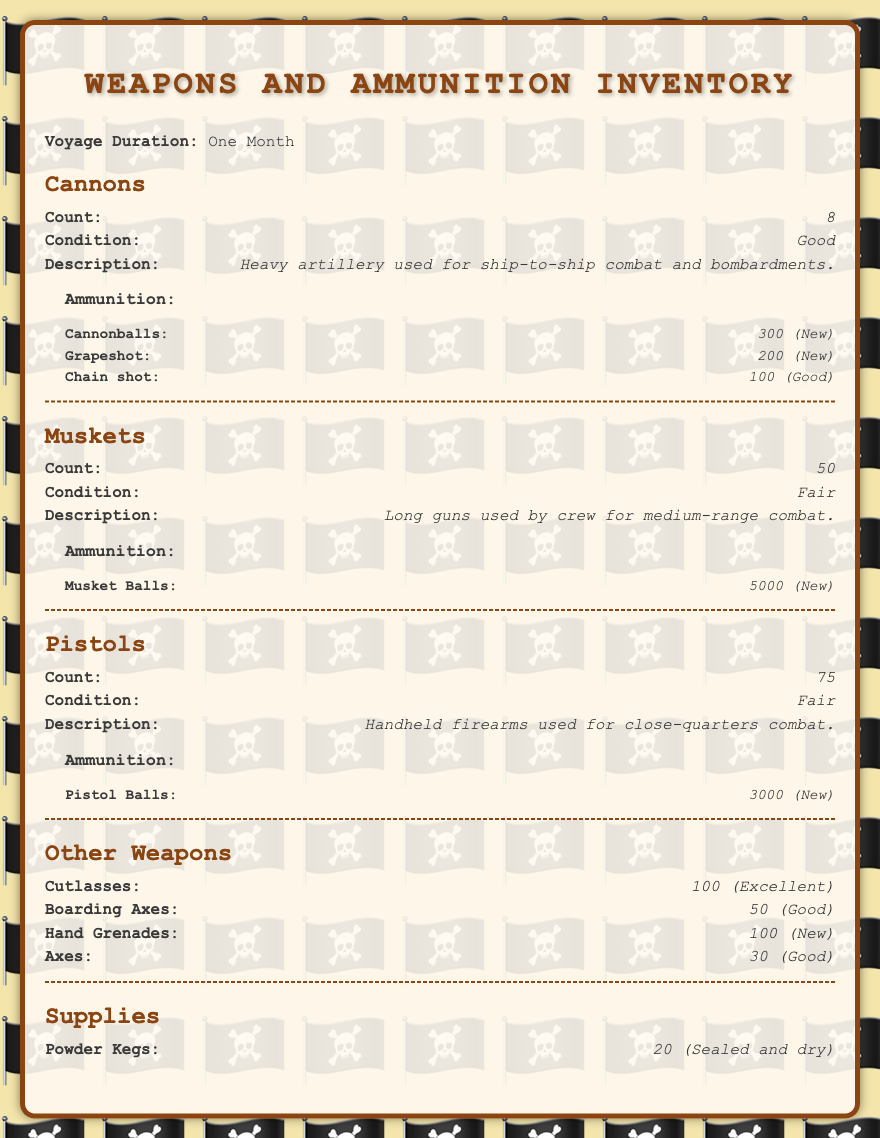what is the count of cannons? The count of cannons is listed under the Cannons section in the document, which states 8.
Answer: 8 what is the condition of muskets? The condition of muskets is mentioned in the Muskets section, which describes them as Fair.
Answer: Fair how many pistol balls are there? The total number of pistol balls can be found in the Pistols section, indicating there are 3000.
Answer: 3000 what is the condition of the cutlasses? The condition of the cutlasses is shown in the Other Weapons section, stating they are in Excellent condition.
Answer: Excellent how many total types of ammunition are listed? The document provides three types of ammunition for Cannons, one for Muskets, and one for Pistols, making a total of 5 types.
Answer: 5 what is the total number of hand grenades? The count of hand grenades is shown in the Other Weapons section, which states there are 100.
Answer: 100 how many powder kegs are included? The document mentions the number of powder kegs in the Supplies section, which states 20.
Answer: 20 which weapon has the highest count? By examining the document, the weapon with the highest count is the muskets with 50.
Answer: 50 